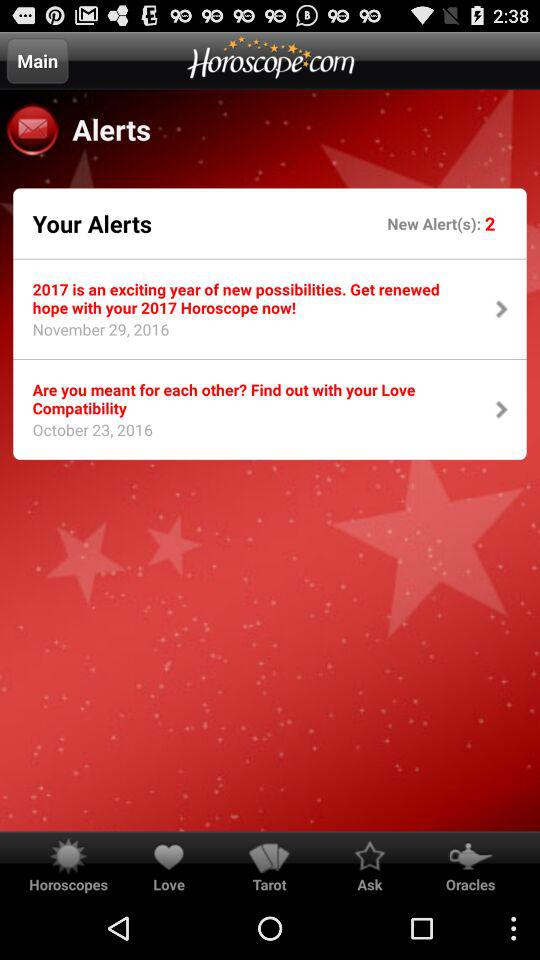Which alert did you receive on October 23, 2016? The alert you received on October 23, 2016 was "Are you meant for each other? Find out with your Love Compatibility". 